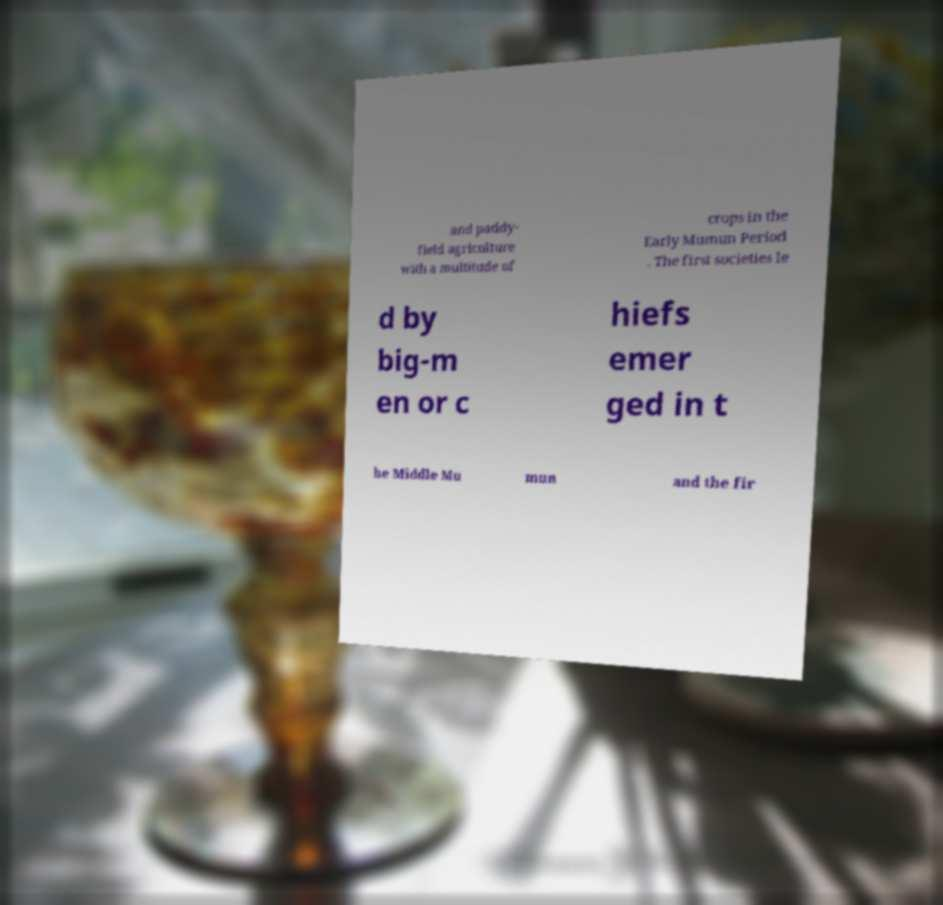Please identify and transcribe the text found in this image. and paddy- field agriculture with a multitude of crops in the Early Mumun Period . The first societies le d by big-m en or c hiefs emer ged in t he Middle Mu mun and the fir 